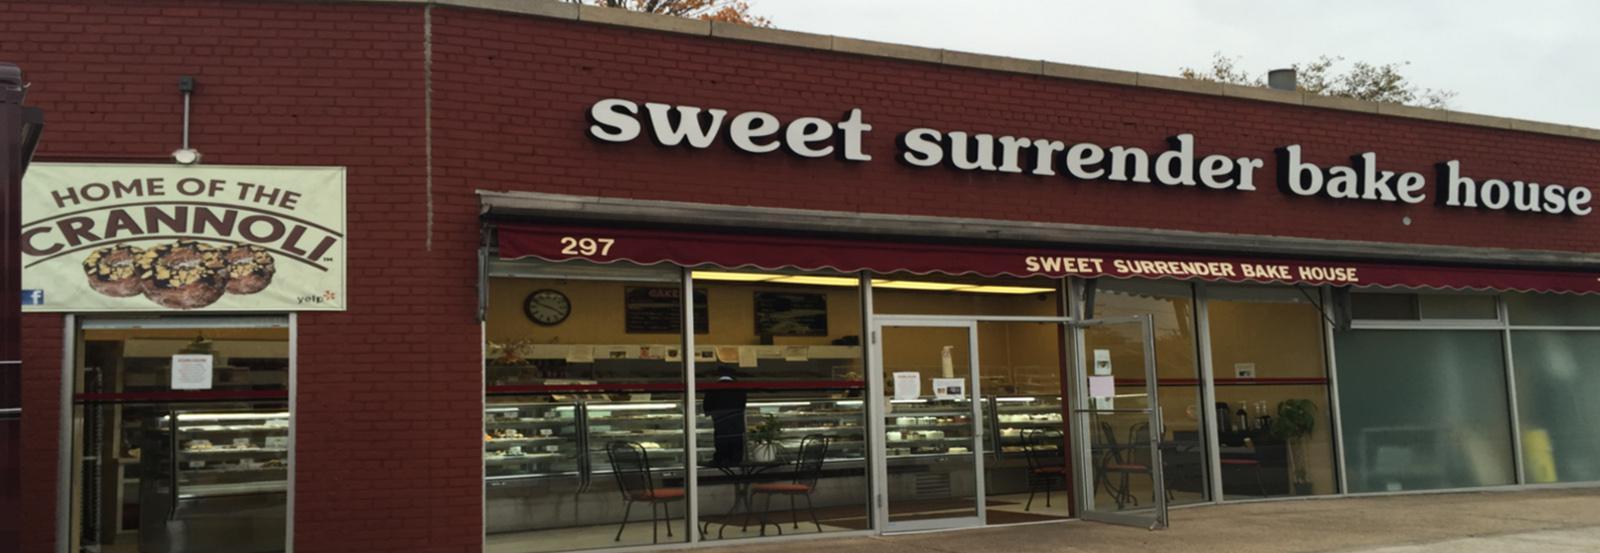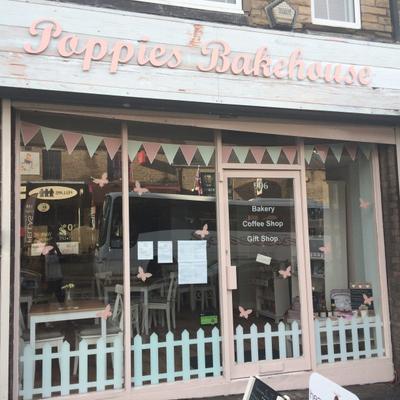The first image is the image on the left, the second image is the image on the right. For the images shown, is this caption "Traingular pennants are on display in the image on the right." true? Answer yes or no. Yes. 